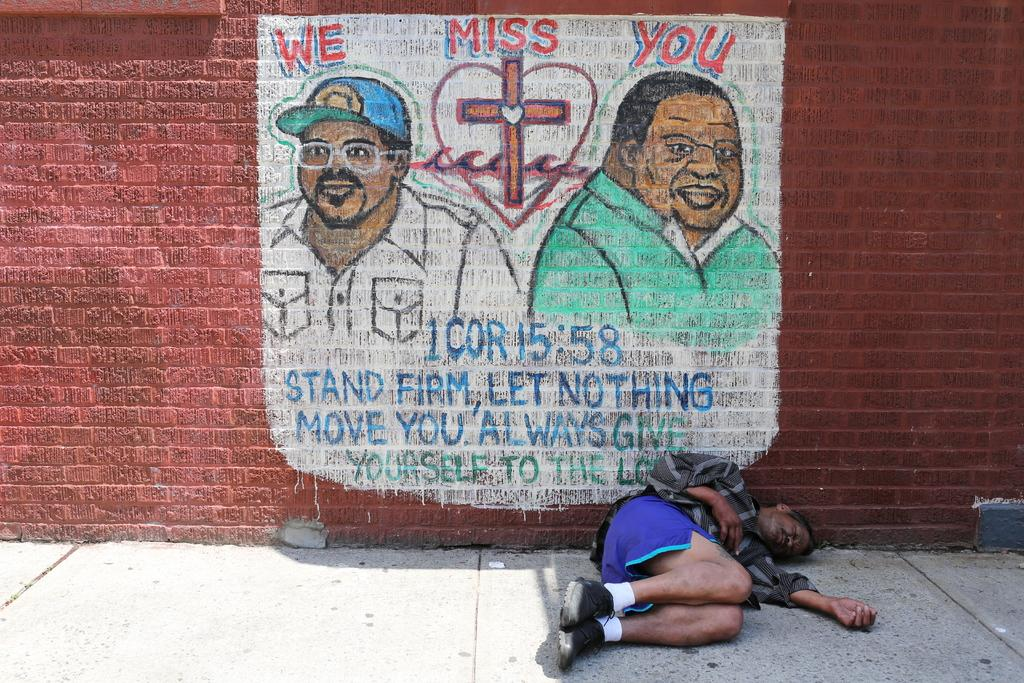Provide a one-sentence caption for the provided image. A man sleeping on a sidewalk underneath a poster stating we miss you. 